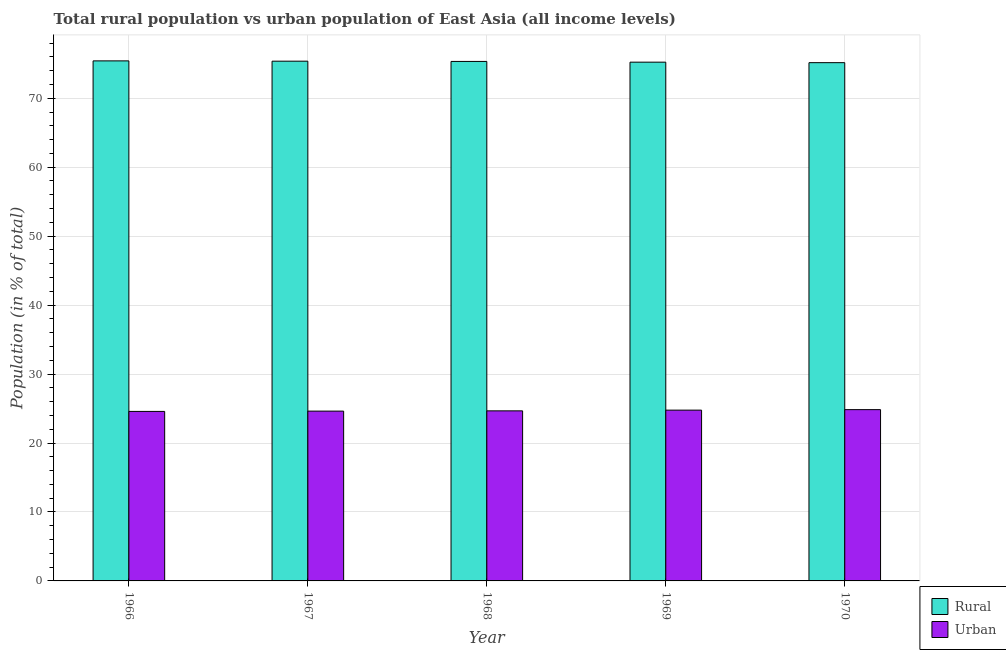How many different coloured bars are there?
Offer a terse response. 2. How many groups of bars are there?
Offer a very short reply. 5. Are the number of bars per tick equal to the number of legend labels?
Give a very brief answer. Yes. Are the number of bars on each tick of the X-axis equal?
Offer a very short reply. Yes. How many bars are there on the 1st tick from the left?
Your response must be concise. 2. How many bars are there on the 3rd tick from the right?
Offer a terse response. 2. What is the label of the 2nd group of bars from the left?
Make the answer very short. 1967. In how many cases, is the number of bars for a given year not equal to the number of legend labels?
Your answer should be compact. 0. What is the rural population in 1968?
Your response must be concise. 75.34. Across all years, what is the maximum urban population?
Make the answer very short. 24.84. Across all years, what is the minimum urban population?
Offer a terse response. 24.58. In which year was the urban population maximum?
Offer a terse response. 1970. In which year was the rural population minimum?
Your answer should be very brief. 1970. What is the total urban population in the graph?
Ensure brevity in your answer.  123.48. What is the difference between the rural population in 1969 and that in 1970?
Your answer should be very brief. 0.07. What is the difference between the urban population in 1968 and the rural population in 1970?
Provide a short and direct response. -0.18. What is the average rural population per year?
Your answer should be very brief. 75.3. What is the ratio of the rural population in 1968 to that in 1970?
Your answer should be compact. 1. What is the difference between the highest and the second highest urban population?
Keep it short and to the point. 0.07. What is the difference between the highest and the lowest urban population?
Ensure brevity in your answer.  0.26. What does the 2nd bar from the left in 1966 represents?
Give a very brief answer. Urban. What does the 1st bar from the right in 1969 represents?
Your answer should be very brief. Urban. How many bars are there?
Give a very brief answer. 10. How many years are there in the graph?
Make the answer very short. 5. What is the difference between two consecutive major ticks on the Y-axis?
Your answer should be very brief. 10. Does the graph contain grids?
Provide a succinct answer. Yes. How many legend labels are there?
Your answer should be very brief. 2. What is the title of the graph?
Your answer should be very brief. Total rural population vs urban population of East Asia (all income levels). What is the label or title of the Y-axis?
Your response must be concise. Population (in % of total). What is the Population (in % of total) in Rural in 1966?
Provide a succinct answer. 75.42. What is the Population (in % of total) in Urban in 1966?
Your answer should be compact. 24.58. What is the Population (in % of total) of Rural in 1967?
Keep it short and to the point. 75.37. What is the Population (in % of total) of Urban in 1967?
Provide a short and direct response. 24.63. What is the Population (in % of total) in Rural in 1968?
Your response must be concise. 75.34. What is the Population (in % of total) of Urban in 1968?
Your answer should be very brief. 24.66. What is the Population (in % of total) in Rural in 1969?
Give a very brief answer. 75.23. What is the Population (in % of total) in Urban in 1969?
Give a very brief answer. 24.77. What is the Population (in % of total) in Rural in 1970?
Offer a terse response. 75.16. What is the Population (in % of total) of Urban in 1970?
Provide a short and direct response. 24.84. Across all years, what is the maximum Population (in % of total) of Rural?
Your answer should be compact. 75.42. Across all years, what is the maximum Population (in % of total) in Urban?
Offer a very short reply. 24.84. Across all years, what is the minimum Population (in % of total) of Rural?
Ensure brevity in your answer.  75.16. Across all years, what is the minimum Population (in % of total) in Urban?
Provide a succinct answer. 24.58. What is the total Population (in % of total) in Rural in the graph?
Your answer should be compact. 376.52. What is the total Population (in % of total) of Urban in the graph?
Ensure brevity in your answer.  123.48. What is the difference between the Population (in % of total) in Rural in 1966 and that in 1967?
Your answer should be compact. 0.04. What is the difference between the Population (in % of total) in Urban in 1966 and that in 1967?
Ensure brevity in your answer.  -0.04. What is the difference between the Population (in % of total) in Rural in 1966 and that in 1968?
Your response must be concise. 0.08. What is the difference between the Population (in % of total) in Urban in 1966 and that in 1968?
Keep it short and to the point. -0.08. What is the difference between the Population (in % of total) in Rural in 1966 and that in 1969?
Your answer should be compact. 0.19. What is the difference between the Population (in % of total) of Urban in 1966 and that in 1969?
Offer a terse response. -0.19. What is the difference between the Population (in % of total) in Rural in 1966 and that in 1970?
Give a very brief answer. 0.26. What is the difference between the Population (in % of total) in Urban in 1966 and that in 1970?
Give a very brief answer. -0.26. What is the difference between the Population (in % of total) in Rural in 1967 and that in 1968?
Provide a succinct answer. 0.04. What is the difference between the Population (in % of total) of Urban in 1967 and that in 1968?
Ensure brevity in your answer.  -0.04. What is the difference between the Population (in % of total) of Rural in 1967 and that in 1969?
Ensure brevity in your answer.  0.14. What is the difference between the Population (in % of total) in Urban in 1967 and that in 1969?
Your answer should be very brief. -0.14. What is the difference between the Population (in % of total) of Rural in 1967 and that in 1970?
Offer a very short reply. 0.21. What is the difference between the Population (in % of total) in Urban in 1967 and that in 1970?
Offer a very short reply. -0.21. What is the difference between the Population (in % of total) in Rural in 1968 and that in 1969?
Offer a terse response. 0.1. What is the difference between the Population (in % of total) in Urban in 1968 and that in 1969?
Offer a terse response. -0.1. What is the difference between the Population (in % of total) in Rural in 1968 and that in 1970?
Your response must be concise. 0.18. What is the difference between the Population (in % of total) of Urban in 1968 and that in 1970?
Offer a very short reply. -0.18. What is the difference between the Population (in % of total) in Rural in 1969 and that in 1970?
Your answer should be compact. 0.07. What is the difference between the Population (in % of total) of Urban in 1969 and that in 1970?
Offer a very short reply. -0.07. What is the difference between the Population (in % of total) of Rural in 1966 and the Population (in % of total) of Urban in 1967?
Keep it short and to the point. 50.79. What is the difference between the Population (in % of total) of Rural in 1966 and the Population (in % of total) of Urban in 1968?
Provide a succinct answer. 50.76. What is the difference between the Population (in % of total) in Rural in 1966 and the Population (in % of total) in Urban in 1969?
Give a very brief answer. 50.65. What is the difference between the Population (in % of total) in Rural in 1966 and the Population (in % of total) in Urban in 1970?
Offer a terse response. 50.58. What is the difference between the Population (in % of total) in Rural in 1967 and the Population (in % of total) in Urban in 1968?
Your answer should be very brief. 50.71. What is the difference between the Population (in % of total) in Rural in 1967 and the Population (in % of total) in Urban in 1969?
Ensure brevity in your answer.  50.61. What is the difference between the Population (in % of total) of Rural in 1967 and the Population (in % of total) of Urban in 1970?
Your answer should be compact. 50.53. What is the difference between the Population (in % of total) in Rural in 1968 and the Population (in % of total) in Urban in 1969?
Your answer should be compact. 50.57. What is the difference between the Population (in % of total) of Rural in 1968 and the Population (in % of total) of Urban in 1970?
Your response must be concise. 50.5. What is the difference between the Population (in % of total) in Rural in 1969 and the Population (in % of total) in Urban in 1970?
Make the answer very short. 50.39. What is the average Population (in % of total) in Rural per year?
Your response must be concise. 75.3. What is the average Population (in % of total) in Urban per year?
Give a very brief answer. 24.7. In the year 1966, what is the difference between the Population (in % of total) of Rural and Population (in % of total) of Urban?
Ensure brevity in your answer.  50.84. In the year 1967, what is the difference between the Population (in % of total) of Rural and Population (in % of total) of Urban?
Provide a short and direct response. 50.75. In the year 1968, what is the difference between the Population (in % of total) in Rural and Population (in % of total) in Urban?
Your response must be concise. 50.67. In the year 1969, what is the difference between the Population (in % of total) in Rural and Population (in % of total) in Urban?
Keep it short and to the point. 50.46. In the year 1970, what is the difference between the Population (in % of total) of Rural and Population (in % of total) of Urban?
Offer a very short reply. 50.32. What is the ratio of the Population (in % of total) in Rural in 1966 to that in 1967?
Provide a succinct answer. 1. What is the ratio of the Population (in % of total) of Rural in 1966 to that in 1968?
Your answer should be very brief. 1. What is the ratio of the Population (in % of total) in Rural in 1966 to that in 1970?
Your answer should be compact. 1. What is the ratio of the Population (in % of total) of Urban in 1966 to that in 1970?
Your response must be concise. 0.99. What is the ratio of the Population (in % of total) of Rural in 1967 to that in 1968?
Provide a succinct answer. 1. What is the ratio of the Population (in % of total) in Urban in 1967 to that in 1968?
Your answer should be very brief. 1. What is the ratio of the Population (in % of total) in Rural in 1967 to that in 1969?
Your answer should be very brief. 1. What is the ratio of the Population (in % of total) of Urban in 1968 to that in 1969?
Keep it short and to the point. 1. What is the ratio of the Population (in % of total) in Rural in 1968 to that in 1970?
Provide a short and direct response. 1. What is the ratio of the Population (in % of total) in Urban in 1968 to that in 1970?
Make the answer very short. 0.99. What is the difference between the highest and the second highest Population (in % of total) of Rural?
Your answer should be very brief. 0.04. What is the difference between the highest and the second highest Population (in % of total) of Urban?
Offer a terse response. 0.07. What is the difference between the highest and the lowest Population (in % of total) in Rural?
Provide a short and direct response. 0.26. What is the difference between the highest and the lowest Population (in % of total) in Urban?
Your answer should be very brief. 0.26. 